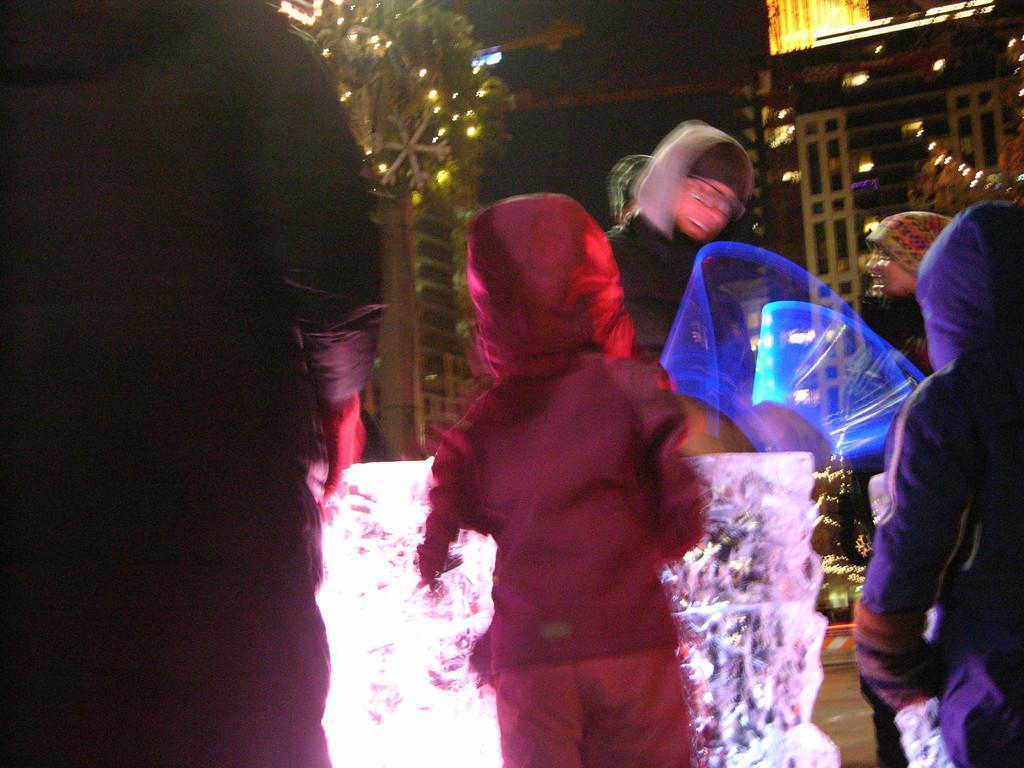Describe this image in one or two sentences. This picture shows a tree and we see a house and few people standing, they wore caps on their heads and we see lighting. 